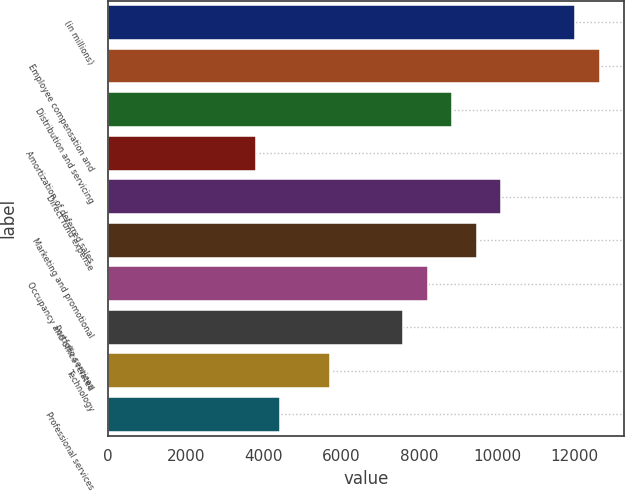Convert chart. <chart><loc_0><loc_0><loc_500><loc_500><bar_chart><fcel>(in millions)<fcel>Employee compensation and<fcel>Distribution and servicing<fcel>Amortization of deferred sales<fcel>Direct fund expense<fcel>Marketing and promotional<fcel>Occupancy and office related<fcel>Portfolio services<fcel>Technology<fcel>Professional services<nl><fcel>12004.7<fcel>12636<fcel>8848.2<fcel>3797.8<fcel>10110.8<fcel>9479.5<fcel>8216.9<fcel>7585.6<fcel>5691.7<fcel>4429.1<nl></chart> 